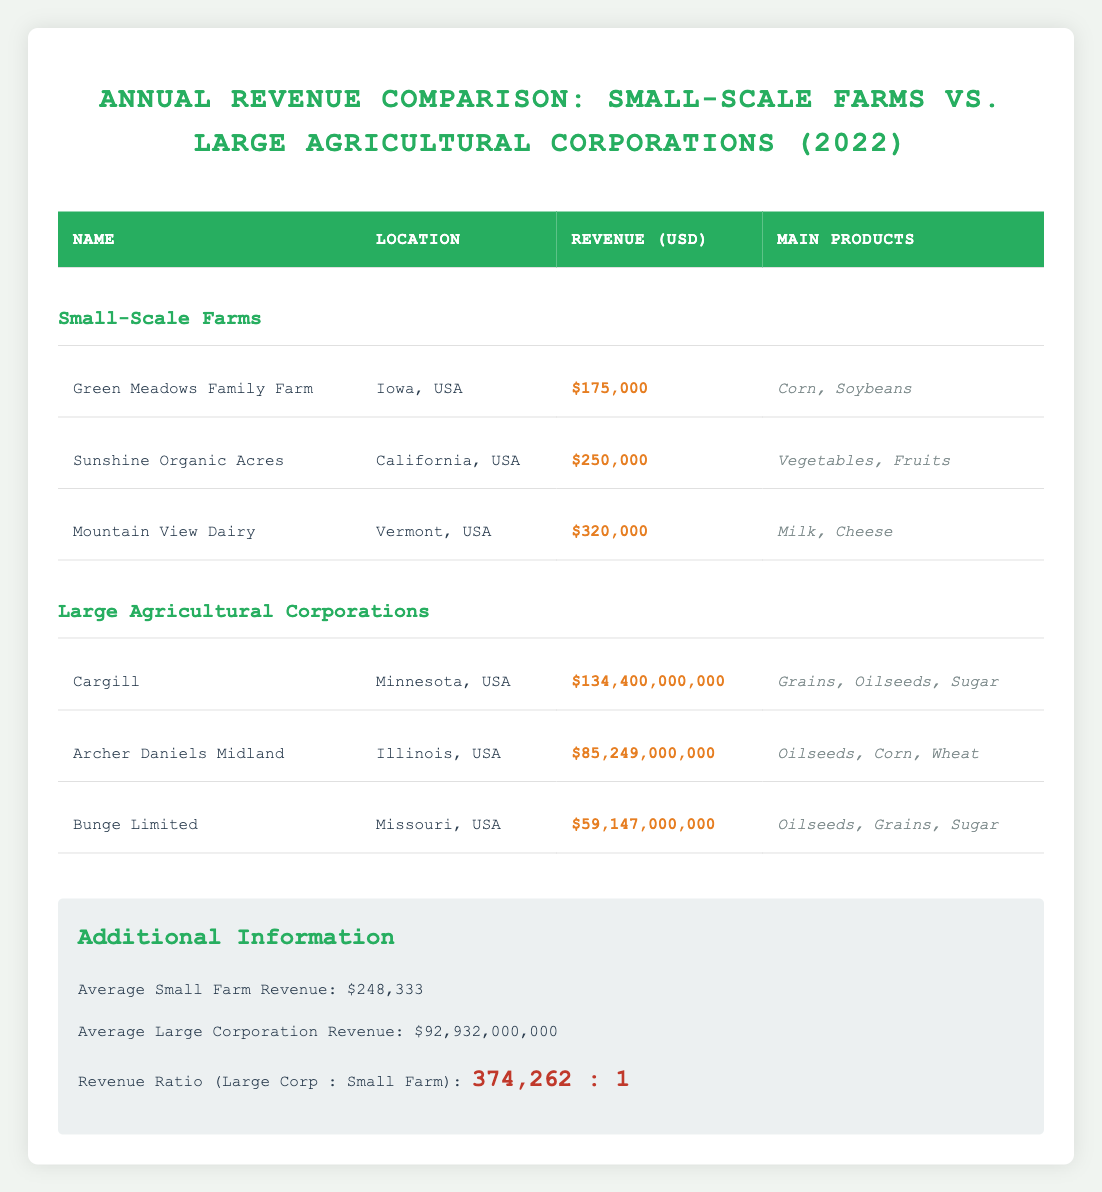What is the revenue of Mountain View Dairy? By locating the row for Mountain View Dairy within the Small-Scale Farms section, the revenue value is directly stated as $320,000.
Answer: $320,000 What is the total revenue from all small-scale farms listed in the table? The revenues are as follows: Green Meadows Family Farm ($175,000), Sunshine Organic Acres ($250,000), and Mountain View Dairy ($320,000). Adding these gives us 175,000 + 250,000 + 320,000 = $745,000.
Answer: $745,000 Is the average revenue of small-scale farms greater than $200,000? The average revenue for small-scale farms is calculated as total revenue ($745,000) divided by the number of farms (3), which gives us $248,333. Since $248,333 is greater than $200,000, the answer is yes.
Answer: Yes What is the revenue ratio of large corporations to small-scale farms? The revenue ratio is given in the additional information section as 374,262:1, indicating that large corporations earn 374,262 times more than small-scale farms.
Answer: 374,262:1 Which entity has the highest revenue among the listed large agricultural corporations? By examining the revenue figures in the Large Agricultural Corporations section, Cargill has the highest revenue listed at $134,400,000,000, higher than the others.
Answer: Cargill What is the average revenue of the large agricultural corporations? The revenues of the corporations are $134,400,000,000 (Cargill), $85,249,000,000 (Archer Daniels Midland), and $59,147,000,000 (Bunge Limited). The sum is $278,796,000,000 and dividing by the number of corporations (3) gives an average of $92,932,000,000.
Answer: $92,932,000,000 Do small-scale farms collectively earn more than Bunge Limited? From our previous calculations, the total revenue from small-scale farms is $745,000. Bunge Limited's revenue is $59,147,000,000. Since $745,000 is less than $59,147,000,000, small-scale farms earn less.
Answer: No What percentage of total revenue of all entities listed is contributed by Sunshine Organic Acres? The total revenue from both small-scale farms ($745,000) and large corporations ($278,796,000,000) amounts to $278,796,745,000. Sunshine Organic Acres earns $250,000. To find the percentage: (250,000 / 278,796,745,000) * 100. This equates to approximately 0.000089.
Answer: 0.000089% What are the main products of Archer Daniels Midland? The main products are clearly listed in the table as Oilseeds, Corn, and Wheat for Archer Daniels Midland.
Answer: Oilseeds, Corn, Wheat 